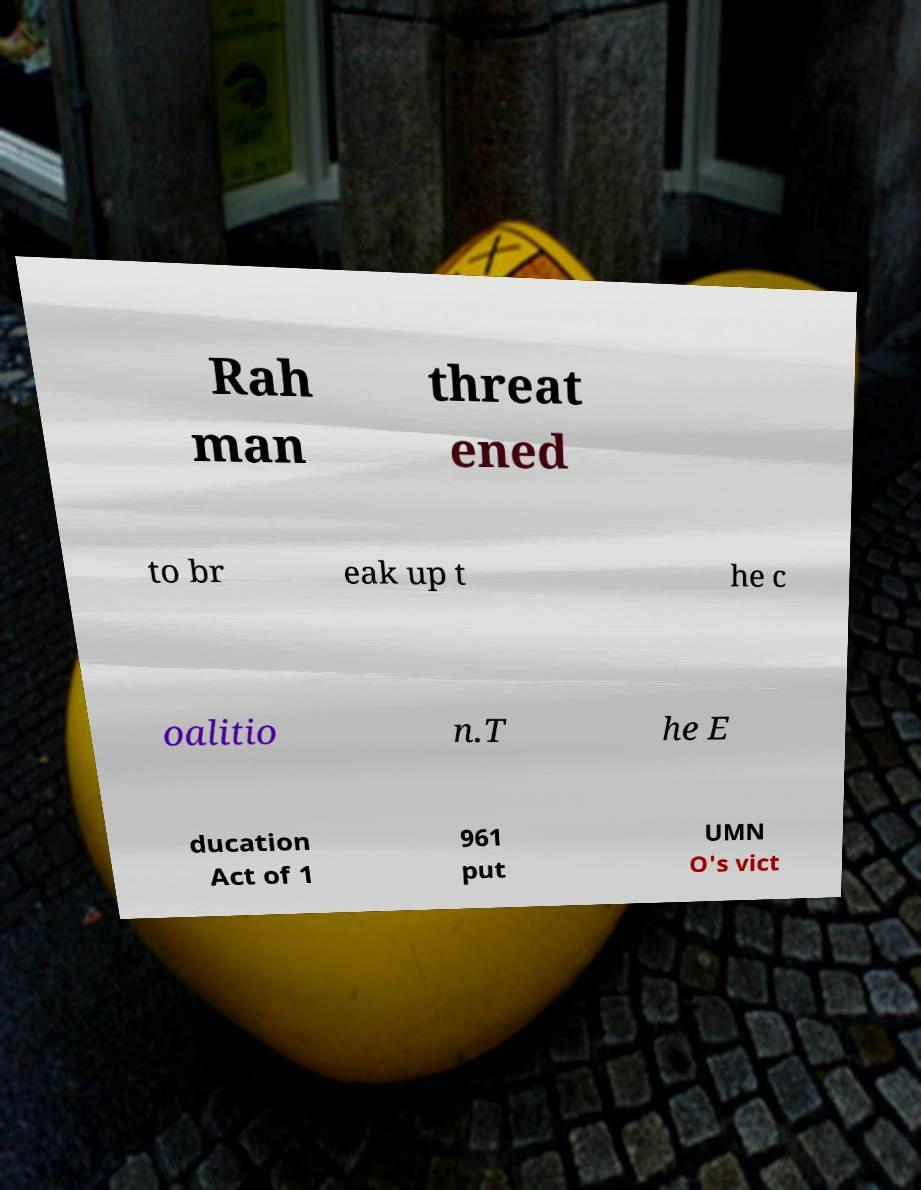Can you read and provide the text displayed in the image?This photo seems to have some interesting text. Can you extract and type it out for me? Rah man threat ened to br eak up t he c oalitio n.T he E ducation Act of 1 961 put UMN O's vict 